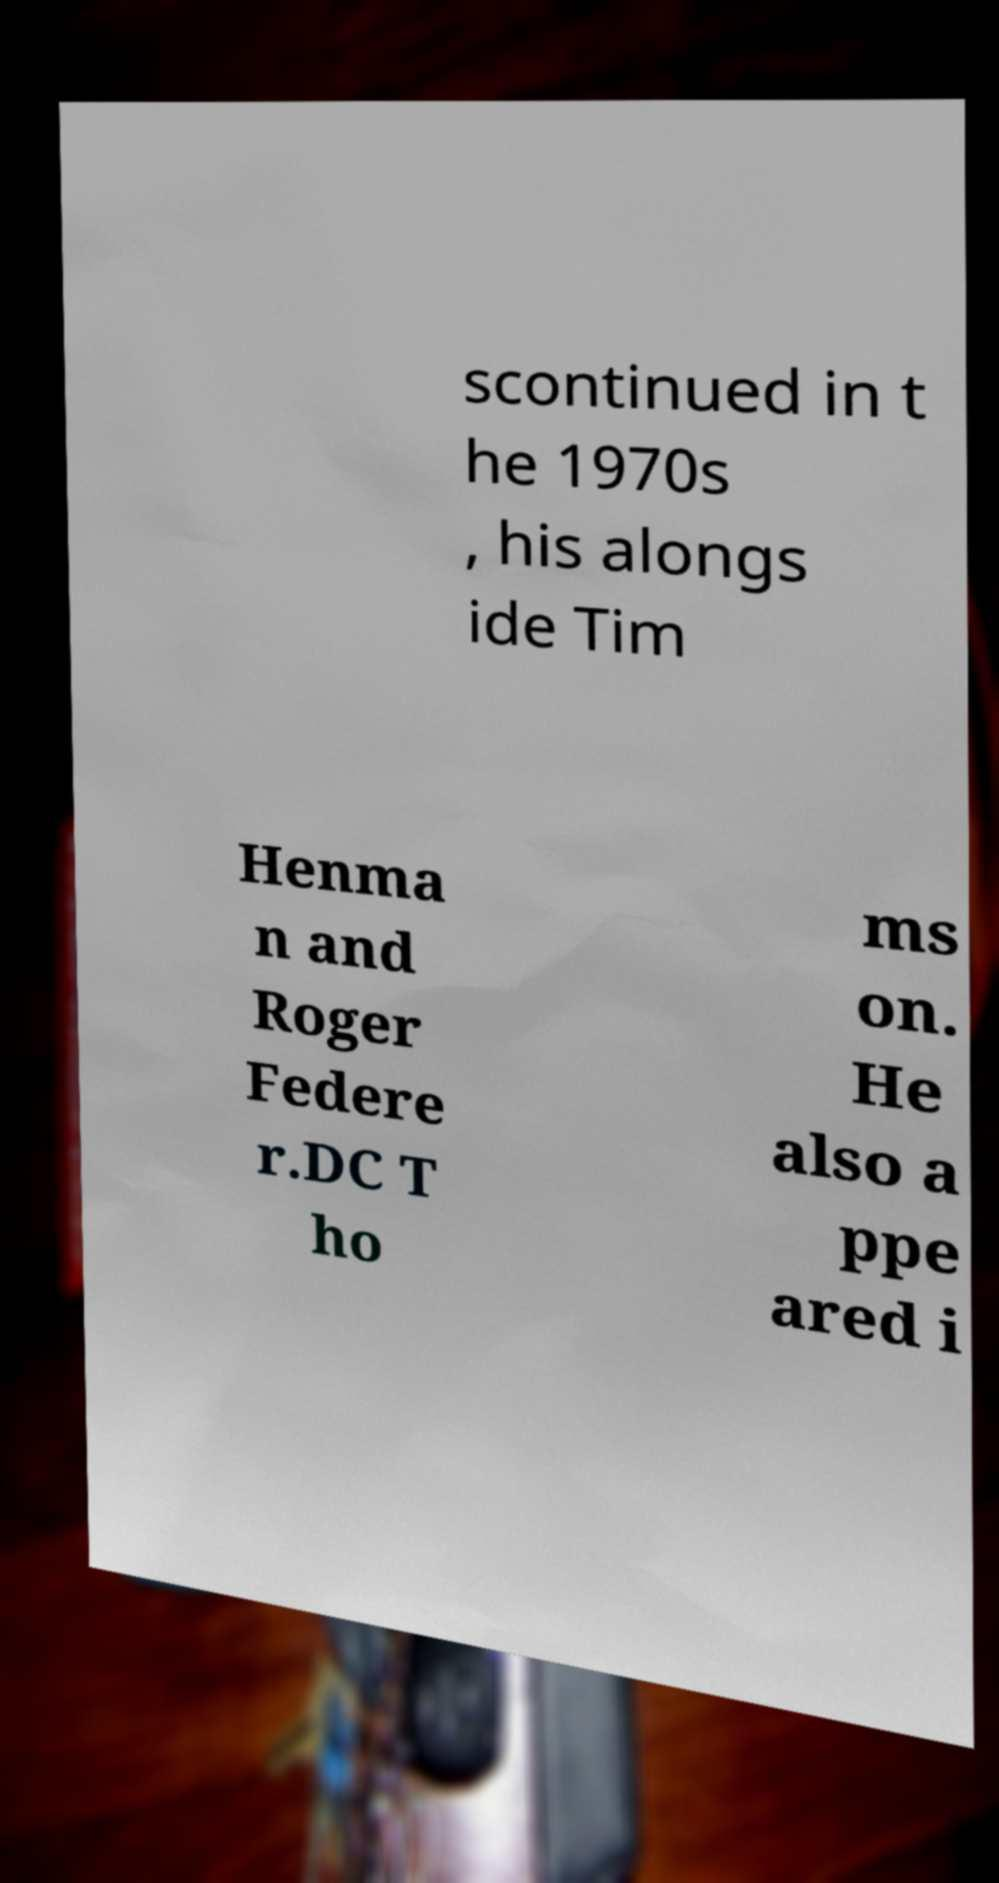Please read and relay the text visible in this image. What does it say? scontinued in t he 1970s , his alongs ide Tim Henma n and Roger Federe r.DC T ho ms on. He also a ppe ared i 